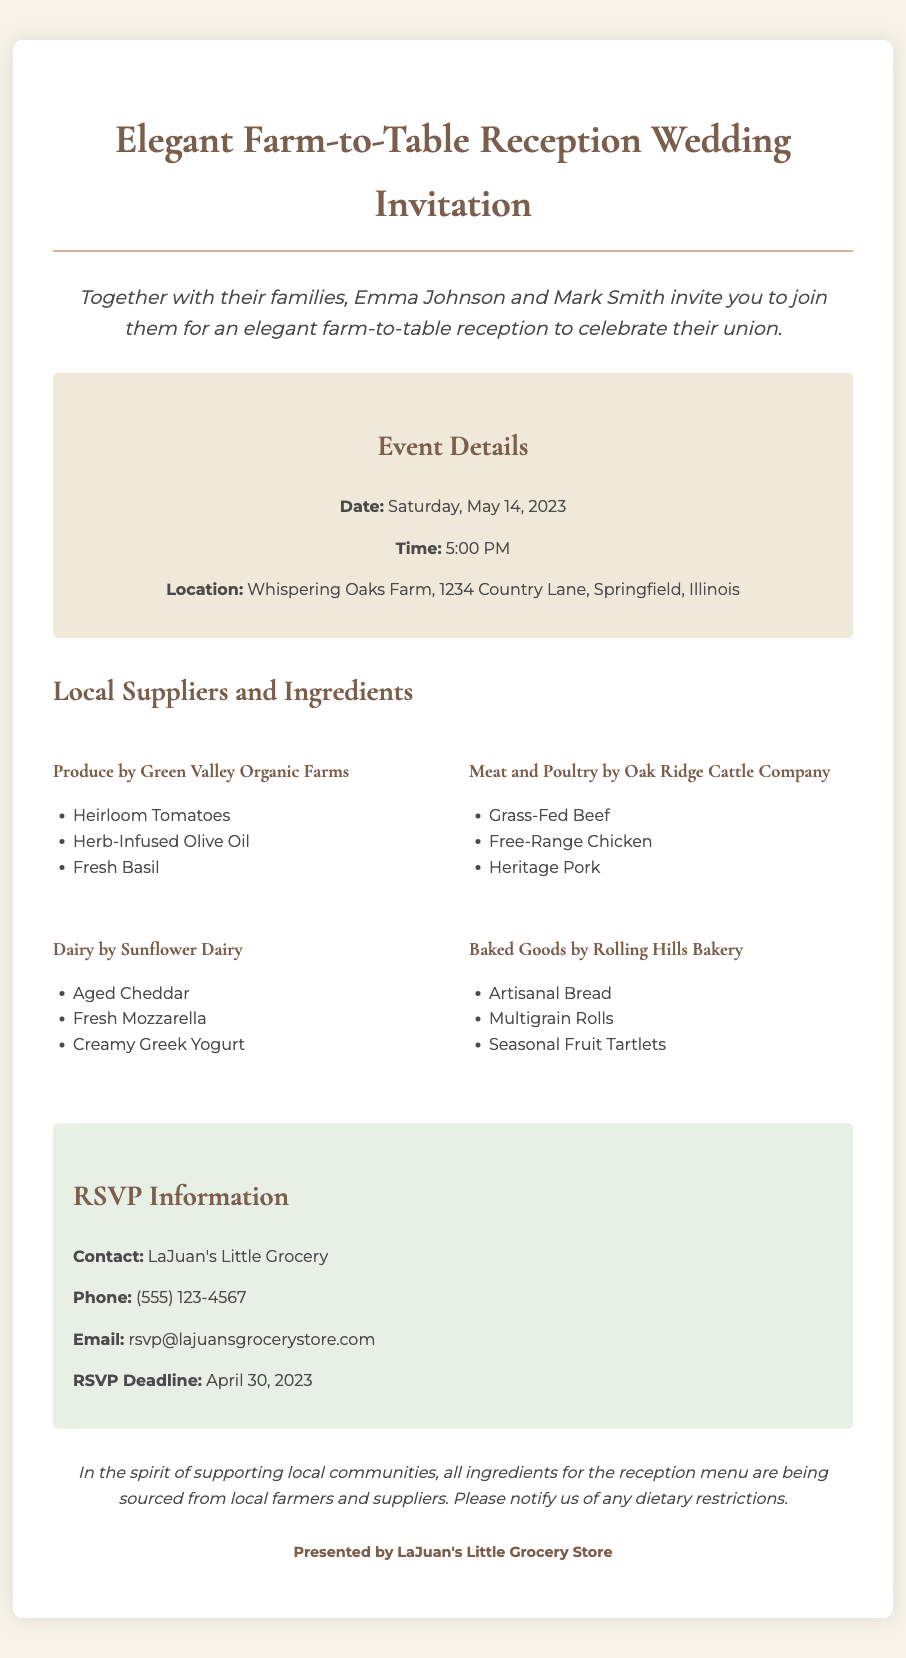What are the names of the couple? The document states that the couple getting married is Emma Johnson and Mark Smith.
Answer: Emma Johnson and Mark Smith What is the wedding date? The document specifies the wedding date as Saturday, May 14, 2023.
Answer: May 14, 2023 Where is the reception being held? The location for the reception is mentioned as Whispering Oaks Farm, 1234 Country Lane, Springfield, Illinois.
Answer: Whispering Oaks Farm, 1234 Country Lane, Springfield, Illinois What is the RSVP deadline? The document indicates that the RSVP deadline is April 30, 2023.
Answer: April 30, 2023 Which supplier provides dairy products? The document lists Sunflower Dairy as the supplier for dairy products.
Answer: Sunflower Dairy What type of meat is provided by Oak Ridge Cattle Company? The document specifies that Oak Ridge Cattle Company provides Grass-Fed Beef, Free-Range Chicken, and Heritage Pork.
Answer: Grass-Fed Beef, Free-Range Chicken, Heritage Pork What is the contact method for RSVPs? The document provides a phone number for RSVPs, which is (555) 123-4567.
Answer: (555) 123-4567 How does the invitation reflect support for local communities? The invitation states that all ingredients for the reception menu are sourced from local farmers and suppliers.
Answer: Sourced from local farmers and suppliers What special note is included for dietary restrictions? The document mentions that guests should notify them of any dietary restrictions.
Answer: Notify us of any dietary restrictions 